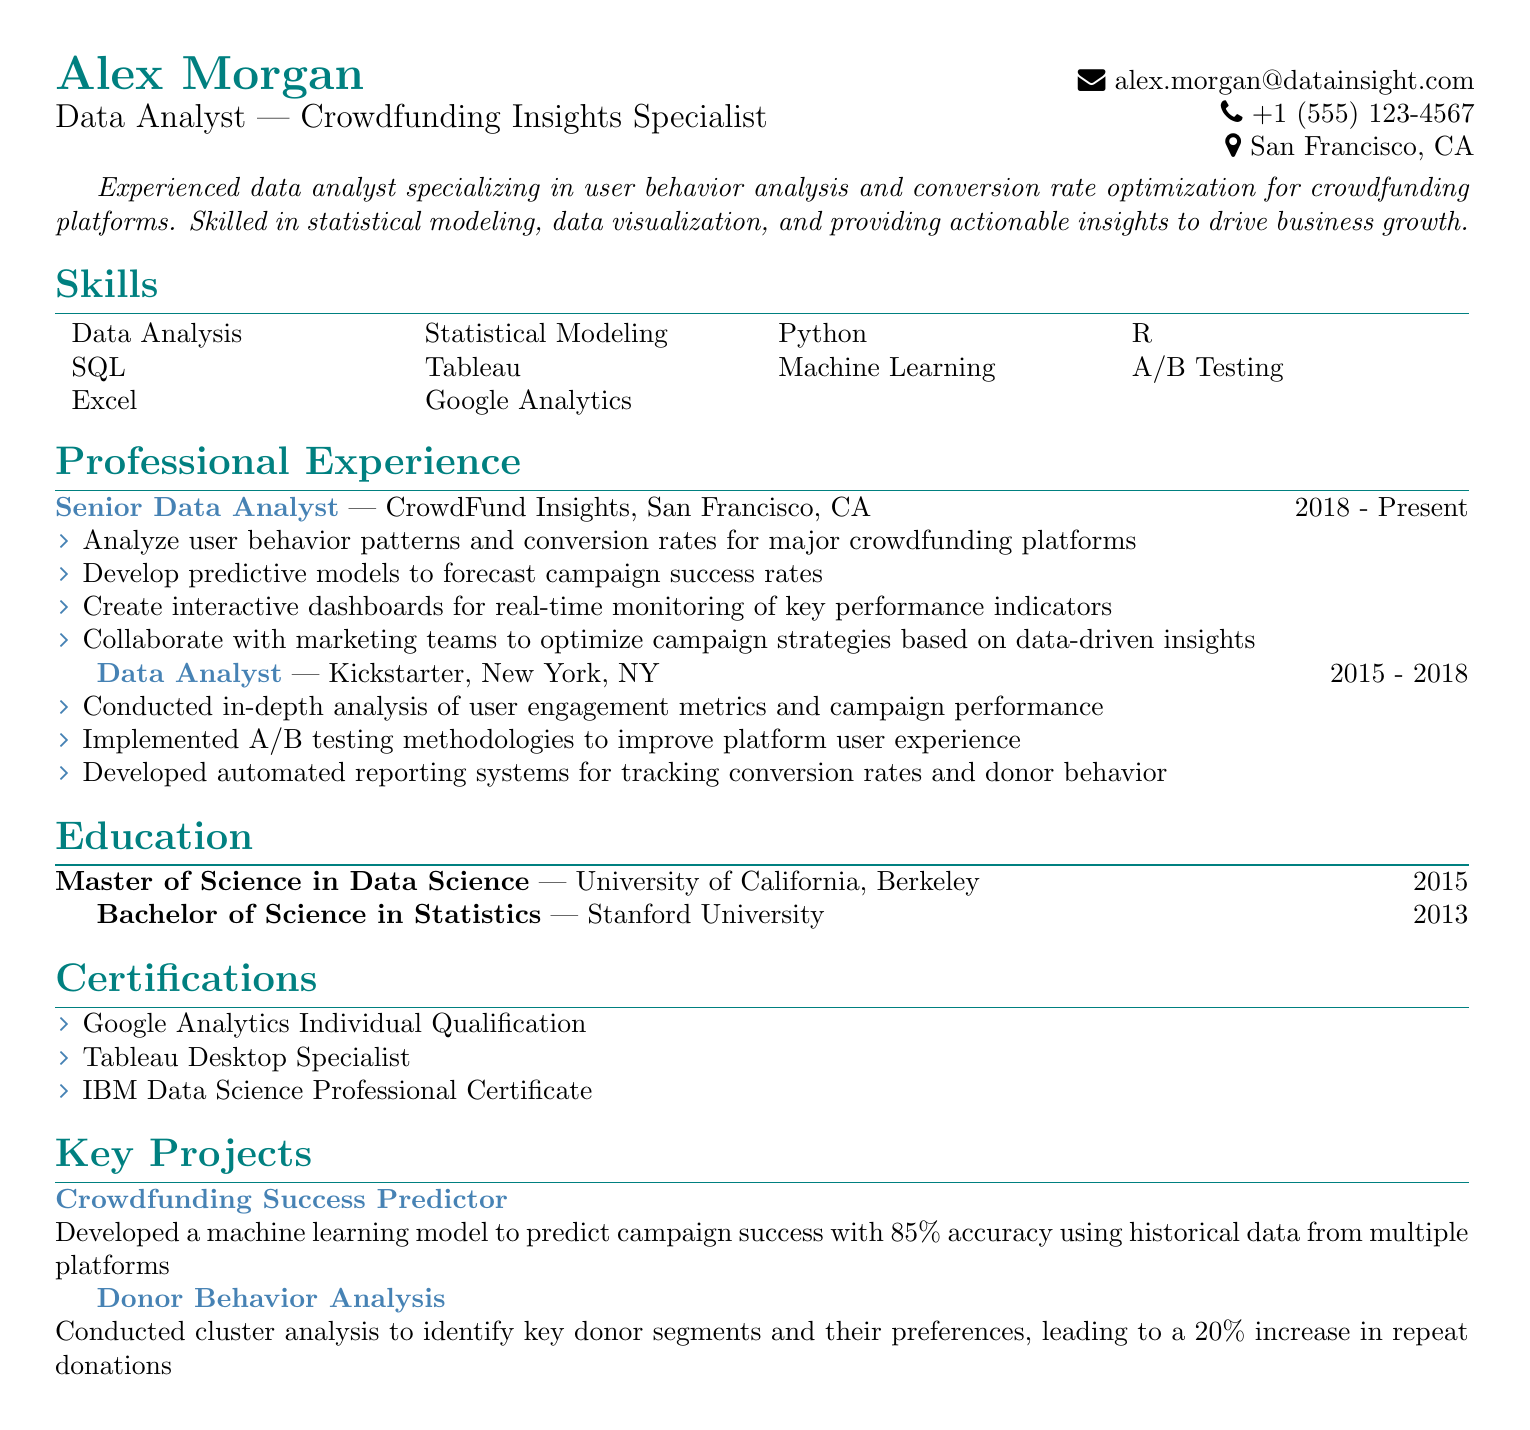What is the name of the individual? The individual's name is stated at the top of the document under personal information.
Answer: Alex Morgan What is the email address provided in the CV? The email address is listed in the contact information section of the CV.
Answer: alex.morgan@datainsight.com What is the duration of Alex Morgan's current position? The duration of the current position is mentioned alongside the job title and company.
Answer: 2018 - Present Which company did Alex Morgan work for prior to CrowdFund Insights? The document lists the previous employment history, showing the company worked for before the current one.
Answer: Kickstarter What degree did Alex Morgan earn from Stanford University? The education section specifies the degree obtained at Stanford University.
Answer: Bachelor of Science in Statistics What is one key skill Alex Morgan possesses? The skills section includes a range of skills relevant to data analysis.
Answer: Data Analysis How many certifications does Alex Morgan have listed? The number of certifications can be found in the certifications section of the CV.
Answer: Three What is the accuracy percentage of the Crowdfunding Success Predictor project? The project description provides specific performance metrics for the project.
Answer: 85% Which city is Alex Morgan located in? The location information is included in the contact details at the beginning of the document.
Answer: San Francisco, CA 